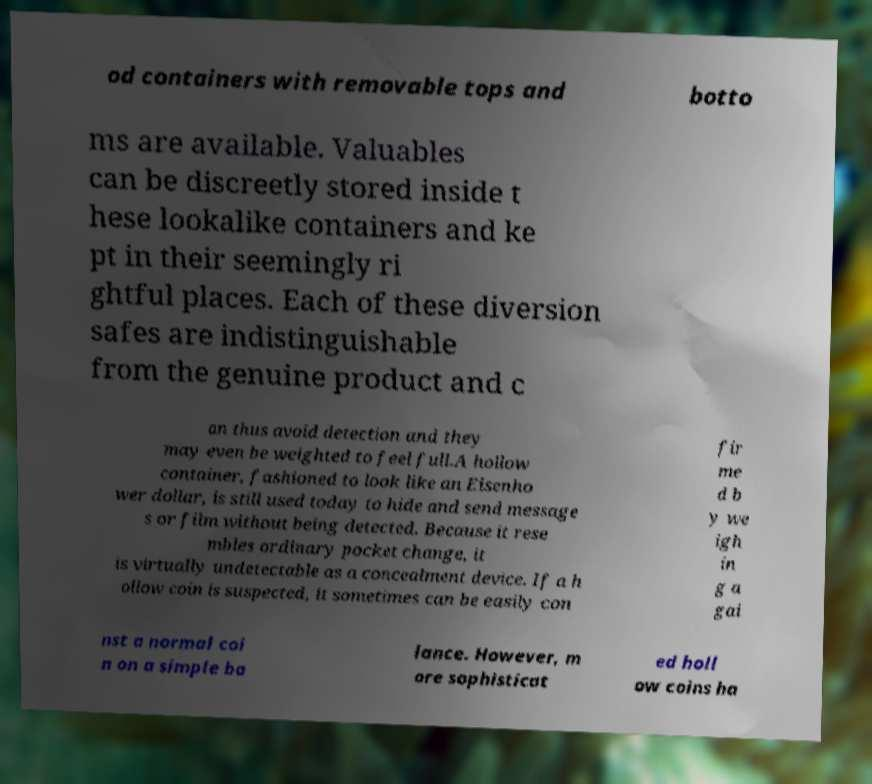Can you accurately transcribe the text from the provided image for me? od containers with removable tops and botto ms are available. Valuables can be discreetly stored inside t hese lookalike containers and ke pt in their seemingly ri ghtful places. Each of these diversion safes are indistinguishable from the genuine product and c an thus avoid detection and they may even be weighted to feel full.A hollow container, fashioned to look like an Eisenho wer dollar, is still used today to hide and send message s or film without being detected. Because it rese mbles ordinary pocket change, it is virtually undetectable as a concealment device. If a h ollow coin is suspected, it sometimes can be easily con fir me d b y we igh in g a gai nst a normal coi n on a simple ba lance. However, m ore sophisticat ed holl ow coins ha 